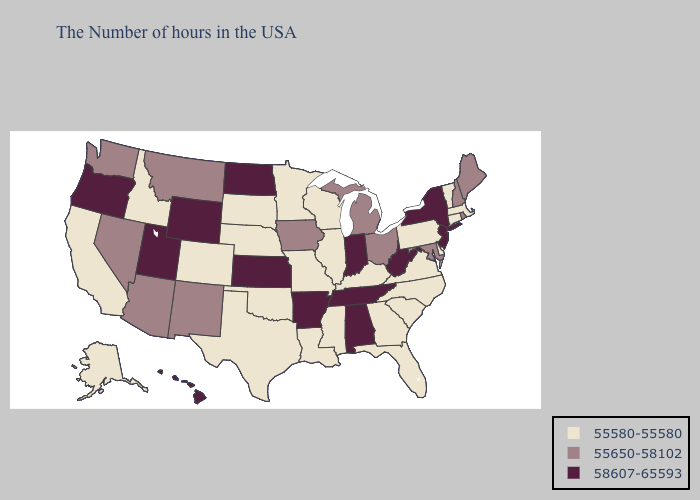Does the first symbol in the legend represent the smallest category?
Keep it brief. Yes. What is the highest value in states that border Iowa?
Give a very brief answer. 55580-55580. Among the states that border Pennsylvania , does Maryland have the highest value?
Write a very short answer. No. What is the lowest value in the South?
Give a very brief answer. 55580-55580. What is the lowest value in states that border Massachusetts?
Short answer required. 55580-55580. Does Arkansas have the highest value in the South?
Answer briefly. Yes. What is the lowest value in the USA?
Concise answer only. 55580-55580. What is the value of Washington?
Give a very brief answer. 55650-58102. Does Virginia have a higher value than Wyoming?
Answer briefly. No. What is the value of Arkansas?
Give a very brief answer. 58607-65593. Name the states that have a value in the range 58607-65593?
Short answer required. New York, New Jersey, West Virginia, Indiana, Alabama, Tennessee, Arkansas, Kansas, North Dakota, Wyoming, Utah, Oregon, Hawaii. Is the legend a continuous bar?
Write a very short answer. No. What is the value of Virginia?
Be succinct. 55580-55580. Which states have the highest value in the USA?
Short answer required. New York, New Jersey, West Virginia, Indiana, Alabama, Tennessee, Arkansas, Kansas, North Dakota, Wyoming, Utah, Oregon, Hawaii. Which states have the lowest value in the MidWest?
Be succinct. Wisconsin, Illinois, Missouri, Minnesota, Nebraska, South Dakota. 